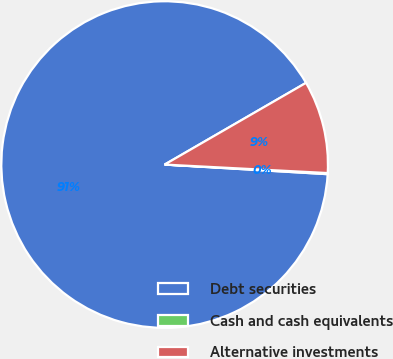Convert chart. <chart><loc_0><loc_0><loc_500><loc_500><pie_chart><fcel>Debt securities<fcel>Cash and cash equivalents<fcel>Alternative investments<nl><fcel>90.72%<fcel>0.11%<fcel>9.17%<nl></chart> 